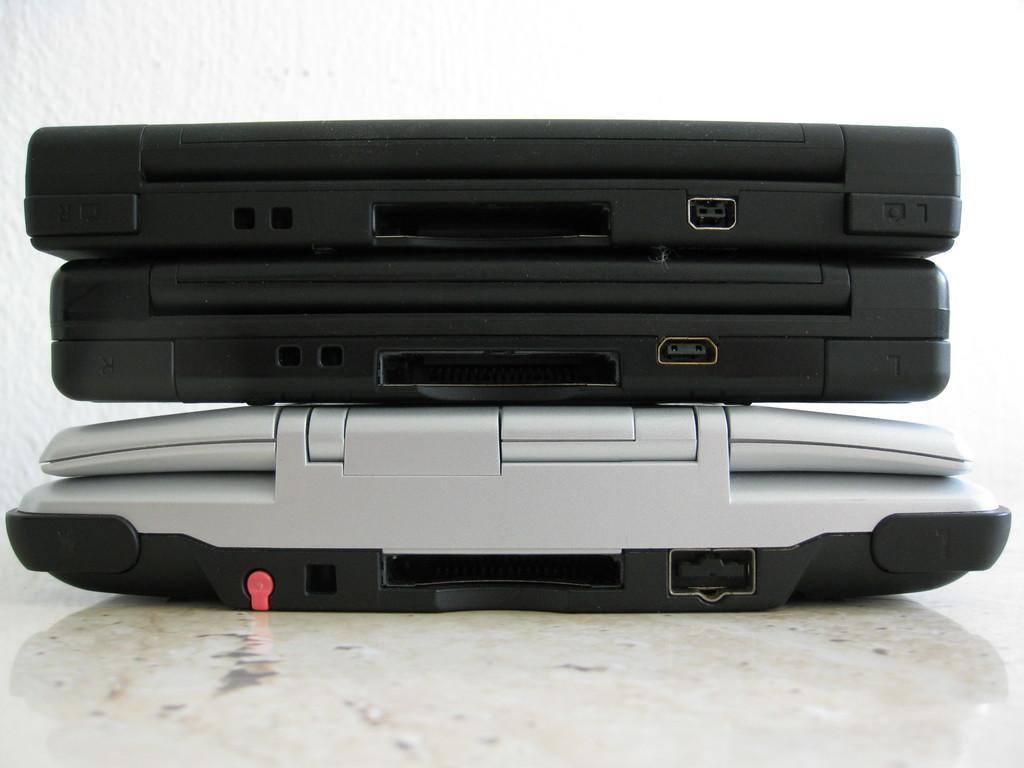Describe this image in one or two sentences. In this image I can see three laptops placed on the floor. In the background there is a wall. 